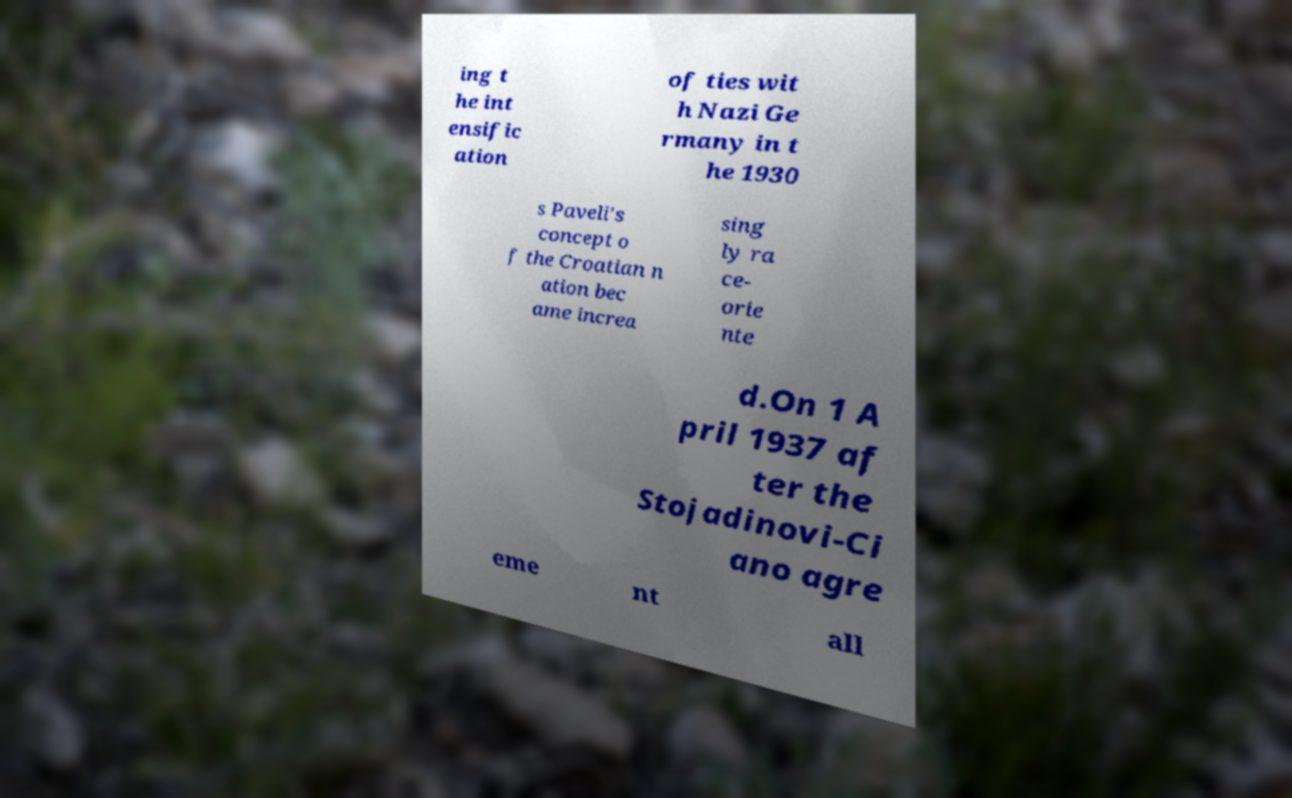Could you extract and type out the text from this image? ing t he int ensific ation of ties wit h Nazi Ge rmany in t he 1930 s Paveli's concept o f the Croatian n ation bec ame increa sing ly ra ce- orie nte d.On 1 A pril 1937 af ter the Stojadinovi-Ci ano agre eme nt all 